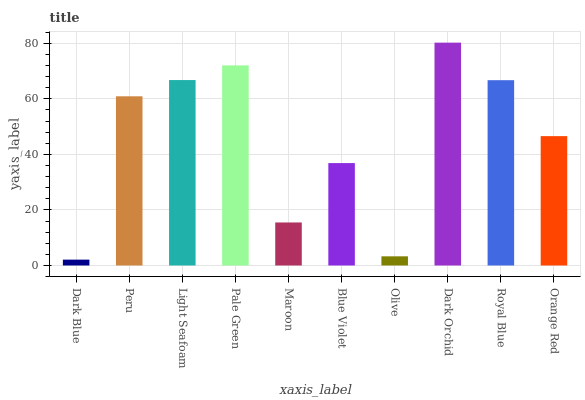Is Dark Blue the minimum?
Answer yes or no. Yes. Is Dark Orchid the maximum?
Answer yes or no. Yes. Is Peru the minimum?
Answer yes or no. No. Is Peru the maximum?
Answer yes or no. No. Is Peru greater than Dark Blue?
Answer yes or no. Yes. Is Dark Blue less than Peru?
Answer yes or no. Yes. Is Dark Blue greater than Peru?
Answer yes or no. No. Is Peru less than Dark Blue?
Answer yes or no. No. Is Peru the high median?
Answer yes or no. Yes. Is Orange Red the low median?
Answer yes or no. Yes. Is Dark Blue the high median?
Answer yes or no. No. Is Light Seafoam the low median?
Answer yes or no. No. 